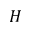Convert formula to latex. <formula><loc_0><loc_0><loc_500><loc_500>H</formula> 